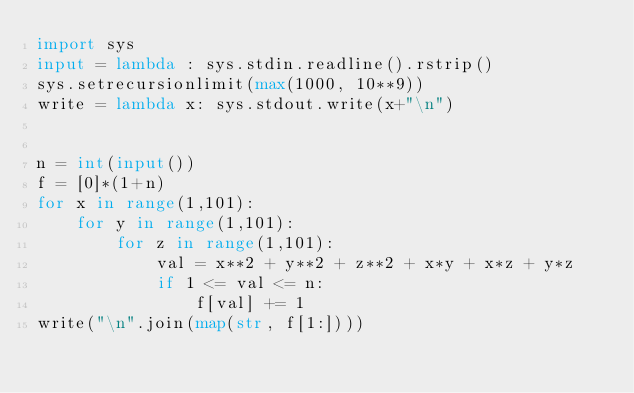<code> <loc_0><loc_0><loc_500><loc_500><_Python_>import sys
input = lambda : sys.stdin.readline().rstrip()
sys.setrecursionlimit(max(1000, 10**9))
write = lambda x: sys.stdout.write(x+"\n")


n = int(input())
f = [0]*(1+n)
for x in range(1,101):
    for y in range(1,101):
        for z in range(1,101):
            val = x**2 + y**2 + z**2 + x*y + x*z + y*z
            if 1 <= val <= n:
                f[val] += 1
write("\n".join(map(str, f[1:])))</code> 